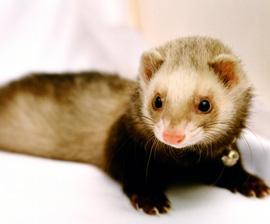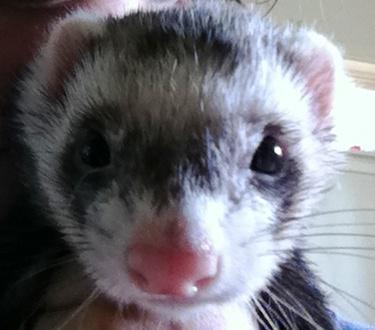The first image is the image on the left, the second image is the image on the right. Analyze the images presented: Is the assertion "The right image shows just one ferret, and it has a mottled brown nose." valid? Answer yes or no. No. 